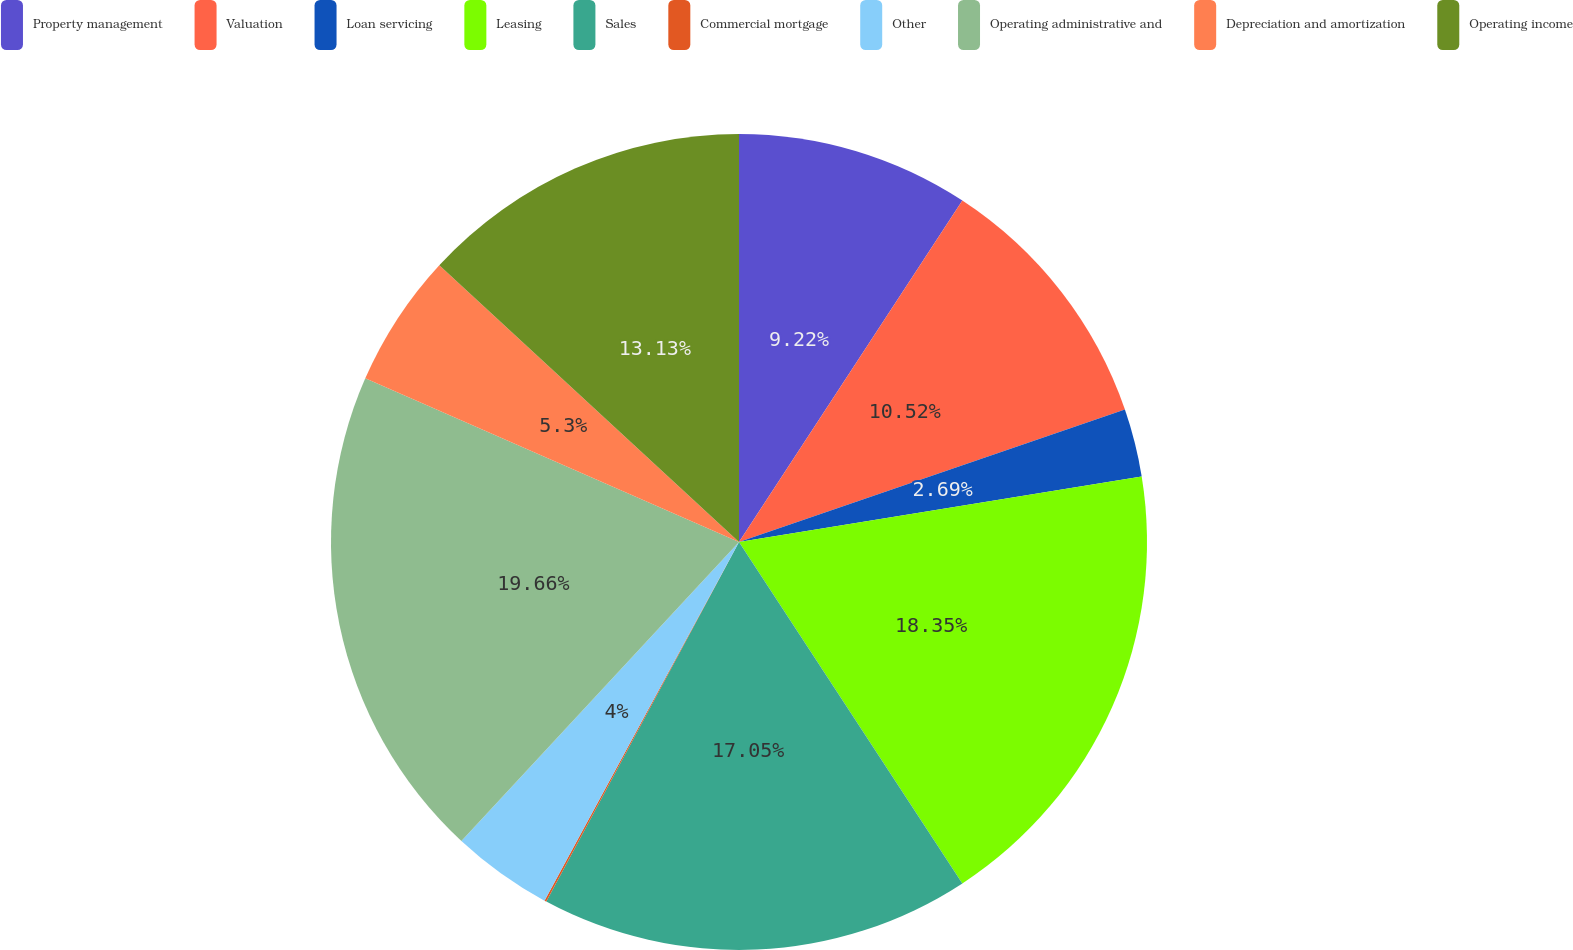Convert chart. <chart><loc_0><loc_0><loc_500><loc_500><pie_chart><fcel>Property management<fcel>Valuation<fcel>Loan servicing<fcel>Leasing<fcel>Sales<fcel>Commercial mortgage<fcel>Other<fcel>Operating administrative and<fcel>Depreciation and amortization<fcel>Operating income<nl><fcel>9.22%<fcel>10.52%<fcel>2.69%<fcel>18.35%<fcel>17.05%<fcel>0.08%<fcel>4.0%<fcel>19.66%<fcel>5.3%<fcel>13.13%<nl></chart> 